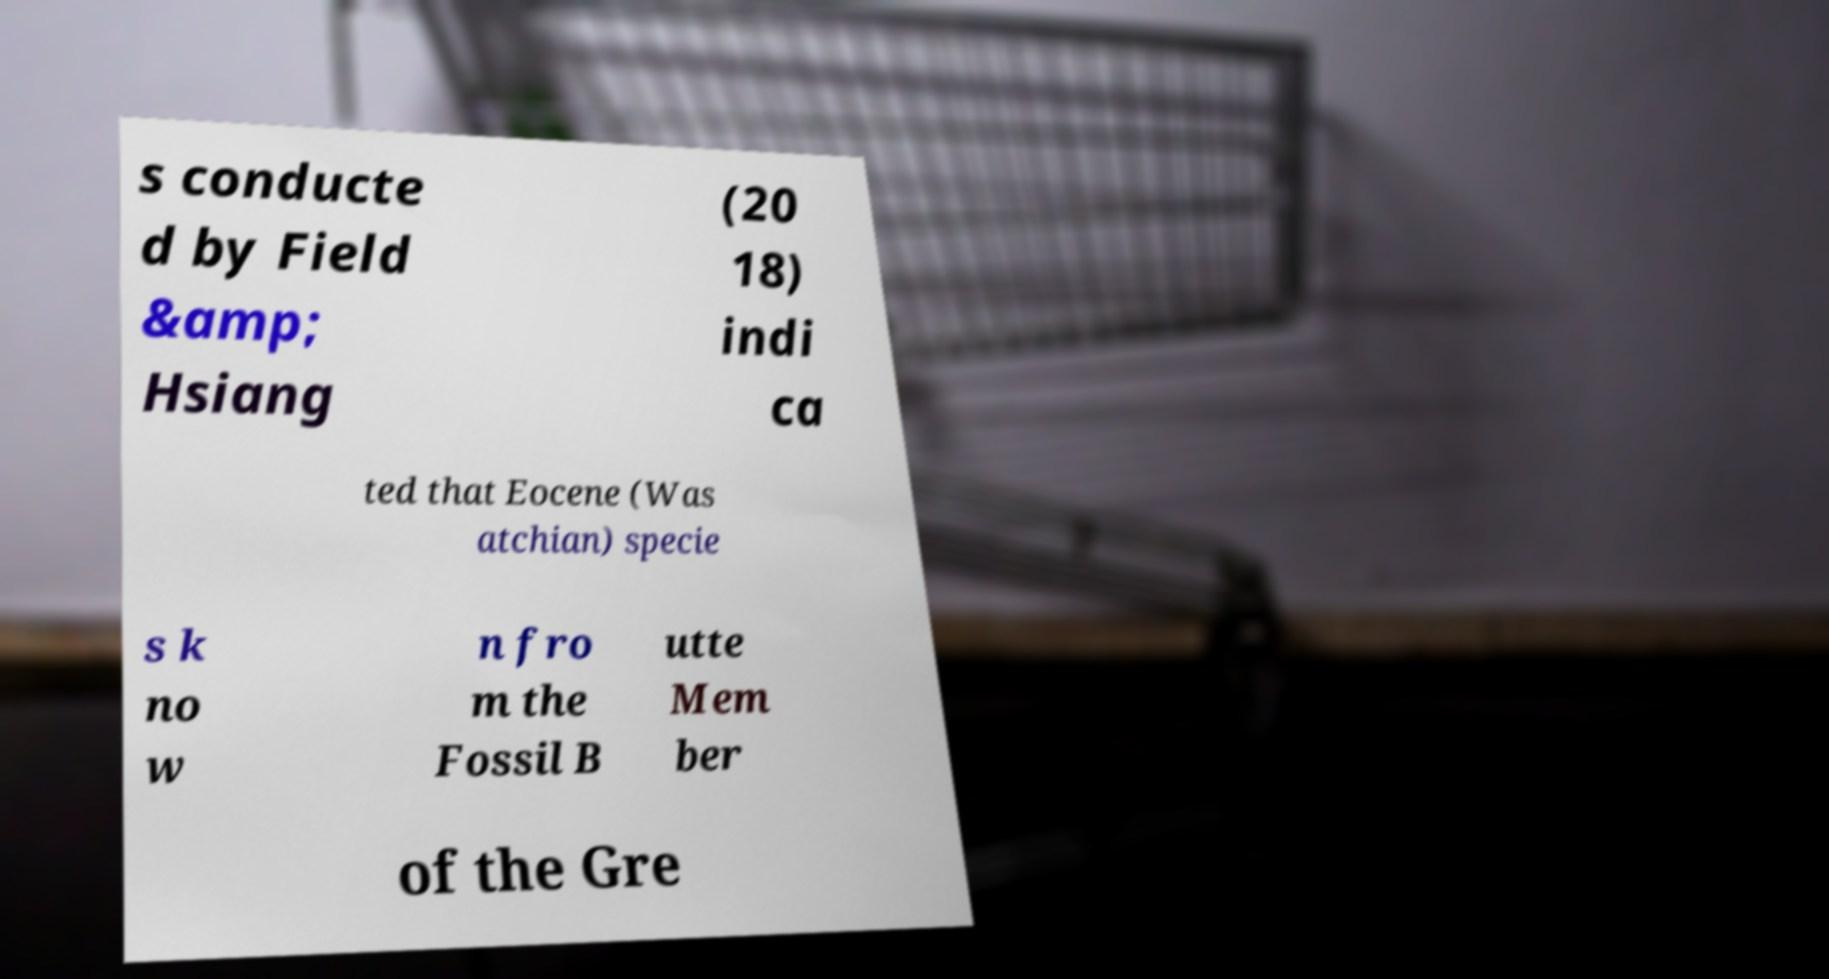There's text embedded in this image that I need extracted. Can you transcribe it verbatim? s conducte d by Field &amp; Hsiang (20 18) indi ca ted that Eocene (Was atchian) specie s k no w n fro m the Fossil B utte Mem ber of the Gre 